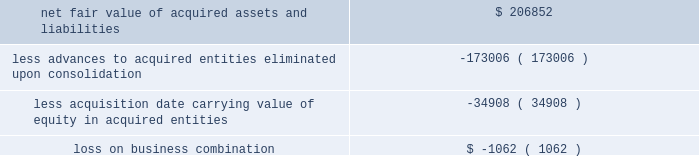58| | duke realty corporation annual report 2009 we recognized a loss of $ 1.1 million upon acquisition , which represents the difference between the fair value of the recognized assets and the carrying value of our pre-existing equity interest .
The acquisition date fair value of the net recognized assets as compared to the acquisition date carrying value of our outstanding advances and accrued interest , as well as the acquisition date carrying value of our pre-existing equity interests , is shown as follows ( in thousands ) : .
Since april 1 , 2009 , the results of operations for both acquired entities have been included in continuing operations in our consolidated financial statements .
Due to our significant pre-existing ownership and financing positions in the two acquired entities , the inclusion of their results of operations did not have a material effect on our operating income .
Acquisitions we acquired income producing real estate related assets of $ 32.1 million , $ 60.5 million and $ 219.9 million in 2009 , 2008 and 2007 , respectively .
In december 2007 , in order to further establish our property positions around strategic port locations , we purchased a portfolio of five industrial buildings in seattle , virginia and houston , as well as approximately 161 acres of undeveloped land and a 12-acre container storage facility in houston .
The total price was $ 89.7 million and was financed in part through assumption of secured debt that had a fair value of $ 34.3 million .
Of the total purchase price , $ 64.1 million was allocated to in-service real estate assets , $ 20.0 million was allocated to undeveloped land and the container storage facility , $ 5.4 million was allocated to lease related intangible assets , and the remaining amount was allocated to acquired working capital related assets and liabilities .
The results of operations for the acquired properties since the date of acquisition have been included in continuing rental operations in our consolidated financial statements .
All other acquisitions were not individually material .
Dispositions we disposed of income producing real estate related assets with gross proceeds of $ 267.0 million , $ 426.2 million and $ 590.4 million in 2009 , 2008 and 2007 , respectively .
We sold five properties in 2009 and seven properties in 2008 to an unconsolidated joint venture .
The gross proceeds totaled $ 84.3 million and $ 226.2 million for the years ended december 31 , 2009 and 2008 , respectively .
In march 2007 , as part of our capital recycling program , we sold a portfolio of eight suburban office properties totaling 894000 square feet in the cleveland market .
The sales price totaled $ 140.4 million , of which we received net proceeds of $ 139.3 million .
We also sold a portfolio of twelve flex and light industrial properties in july 2007 , totaling 865000 square feet in the st .
Louis market , for a sales price of $ 65.0 million , of which we received net proceeds of $ 64.2 million .
All other dispositions were not individually material .
( 4 ) related party transactions we provide property management , leasing , construction and other tenant related services to unconsolidated companies in which we have equity interests .
For the years ended december 31 , 2009 , 2008 and 2007 , respectively , we earned management fees of $ 8.4 million , $ 7.8 million and $ 7.1 million , leasing fees of $ 4.2 million , $ 2.8 million and $ 4.2 million and construction and development fees of $ 10.2 million , $ 12.7 million and $ 13.1 million from these companies .
We recorded these fees based on contractual terms that approximate market rates for these types of .
What was the ratio of the net fair value of acquired assets and liabilities to the advances and equity? 
Rationale: the net fair value of the assets and liabilities was less that the advances and equity assumed in the transaction at 0.99 to 1
Computations: ((173006 + 34908) / 206852)
Answer: 1.00513. 